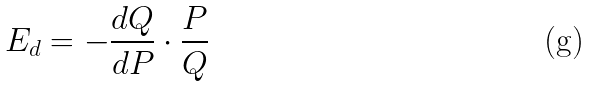<formula> <loc_0><loc_0><loc_500><loc_500>E _ { d } = - \frac { d Q } { d P } \cdot \frac { P } { Q }</formula> 